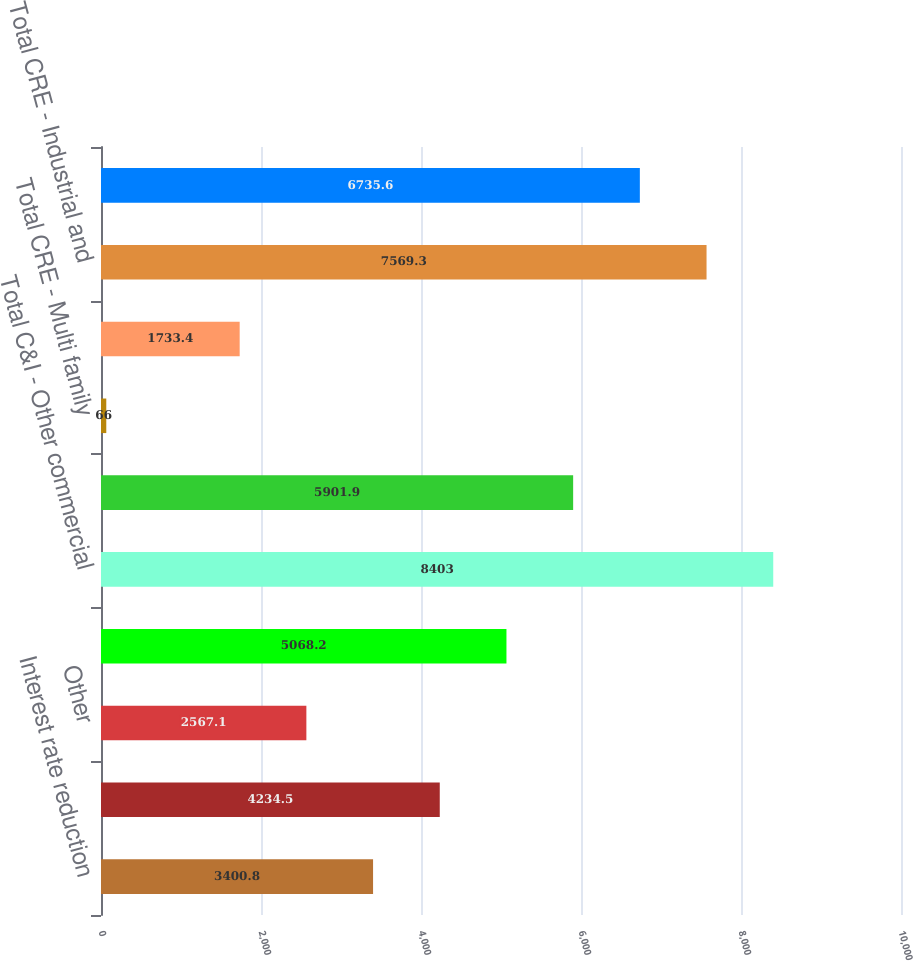<chart> <loc_0><loc_0><loc_500><loc_500><bar_chart><fcel>Interest rate reduction<fcel>Amortization or maturity date<fcel>Other<fcel>Total C&I - Owner occupied<fcel>Total C&I - Other commercial<fcel>Total CRE - Retail properties<fcel>Total CRE - Multi family<fcel>Total CRE - Office<fcel>Total CRE - Industrial and<fcel>Total CRE - Other commercial<nl><fcel>3400.8<fcel>4234.5<fcel>2567.1<fcel>5068.2<fcel>8403<fcel>5901.9<fcel>66<fcel>1733.4<fcel>7569.3<fcel>6735.6<nl></chart> 